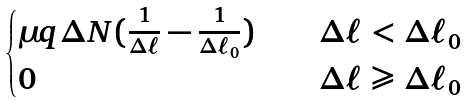Convert formula to latex. <formula><loc_0><loc_0><loc_500><loc_500>\begin{cases} \mu q \Delta N ( \frac { 1 } { \Delta \ell } - \frac { 1 } { \Delta \ell _ { 0 } } ) & \quad \Delta \ell < \Delta \ell _ { 0 } \\ 0 & \quad \Delta \ell \geqslant \Delta \ell _ { 0 } \end{cases}</formula> 